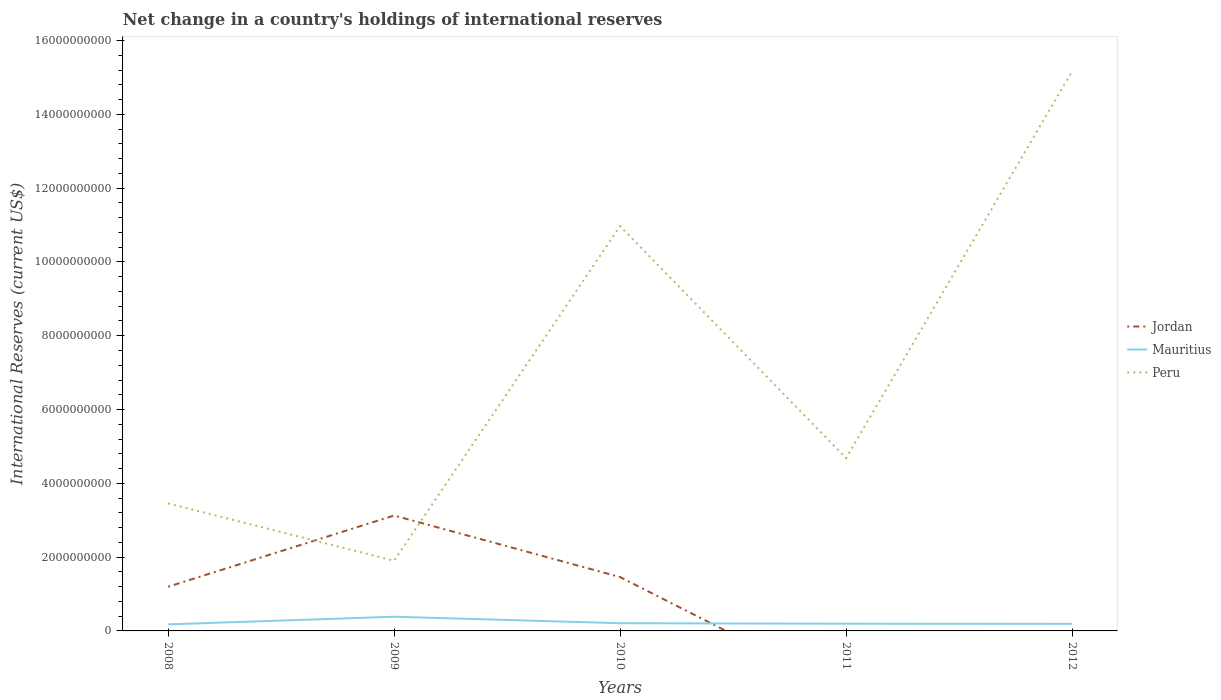Does the line corresponding to Jordan intersect with the line corresponding to Mauritius?
Your response must be concise. Yes. Is the number of lines equal to the number of legend labels?
Ensure brevity in your answer.  No. Across all years, what is the maximum international reserves in Mauritius?
Provide a short and direct response. 1.78e+08. What is the total international reserves in Mauritius in the graph?
Your answer should be very brief. -1.72e+07. What is the difference between the highest and the second highest international reserves in Peru?
Provide a succinct answer. 1.33e+1. How many lines are there?
Offer a terse response. 3. Does the graph contain any zero values?
Give a very brief answer. Yes. Where does the legend appear in the graph?
Make the answer very short. Center right. How many legend labels are there?
Your answer should be very brief. 3. What is the title of the graph?
Make the answer very short. Net change in a country's holdings of international reserves. Does "Heavily indebted poor countries" appear as one of the legend labels in the graph?
Offer a very short reply. No. What is the label or title of the X-axis?
Your answer should be very brief. Years. What is the label or title of the Y-axis?
Make the answer very short. International Reserves (current US$). What is the International Reserves (current US$) in Jordan in 2008?
Provide a succinct answer. 1.20e+09. What is the International Reserves (current US$) of Mauritius in 2008?
Provide a short and direct response. 1.78e+08. What is the International Reserves (current US$) of Peru in 2008?
Ensure brevity in your answer.  3.46e+09. What is the International Reserves (current US$) of Jordan in 2009?
Ensure brevity in your answer.  3.13e+09. What is the International Reserves (current US$) in Mauritius in 2009?
Your answer should be very brief. 3.85e+08. What is the International Reserves (current US$) in Peru in 2009?
Ensure brevity in your answer.  1.90e+09. What is the International Reserves (current US$) of Jordan in 2010?
Ensure brevity in your answer.  1.46e+09. What is the International Reserves (current US$) in Mauritius in 2010?
Provide a succinct answer. 2.09e+08. What is the International Reserves (current US$) of Peru in 2010?
Keep it short and to the point. 1.10e+1. What is the International Reserves (current US$) in Jordan in 2011?
Your answer should be very brief. 0. What is the International Reserves (current US$) in Mauritius in 2011?
Provide a succinct answer. 1.95e+08. What is the International Reserves (current US$) in Peru in 2011?
Provide a succinct answer. 4.68e+09. What is the International Reserves (current US$) of Jordan in 2012?
Your answer should be very brief. 0. What is the International Reserves (current US$) of Mauritius in 2012?
Your answer should be very brief. 1.92e+08. What is the International Reserves (current US$) in Peru in 2012?
Make the answer very short. 1.52e+1. Across all years, what is the maximum International Reserves (current US$) of Jordan?
Make the answer very short. 3.13e+09. Across all years, what is the maximum International Reserves (current US$) in Mauritius?
Make the answer very short. 3.85e+08. Across all years, what is the maximum International Reserves (current US$) in Peru?
Your answer should be compact. 1.52e+1. Across all years, what is the minimum International Reserves (current US$) in Mauritius?
Your answer should be very brief. 1.78e+08. Across all years, what is the minimum International Reserves (current US$) of Peru?
Offer a very short reply. 1.90e+09. What is the total International Reserves (current US$) in Jordan in the graph?
Give a very brief answer. 5.78e+09. What is the total International Reserves (current US$) in Mauritius in the graph?
Your response must be concise. 1.16e+09. What is the total International Reserves (current US$) of Peru in the graph?
Offer a terse response. 3.62e+1. What is the difference between the International Reserves (current US$) of Jordan in 2008 and that in 2009?
Your answer should be compact. -1.93e+09. What is the difference between the International Reserves (current US$) in Mauritius in 2008 and that in 2009?
Your answer should be compact. -2.07e+08. What is the difference between the International Reserves (current US$) in Peru in 2008 and that in 2009?
Offer a very short reply. 1.55e+09. What is the difference between the International Reserves (current US$) in Jordan in 2008 and that in 2010?
Your answer should be compact. -2.63e+08. What is the difference between the International Reserves (current US$) of Mauritius in 2008 and that in 2010?
Give a very brief answer. -3.12e+07. What is the difference between the International Reserves (current US$) in Peru in 2008 and that in 2010?
Give a very brief answer. -7.51e+09. What is the difference between the International Reserves (current US$) of Mauritius in 2008 and that in 2011?
Keep it short and to the point. -1.72e+07. What is the difference between the International Reserves (current US$) in Peru in 2008 and that in 2011?
Your answer should be compact. -1.23e+09. What is the difference between the International Reserves (current US$) in Mauritius in 2008 and that in 2012?
Provide a succinct answer. -1.37e+07. What is the difference between the International Reserves (current US$) of Peru in 2008 and that in 2012?
Your answer should be compact. -1.17e+1. What is the difference between the International Reserves (current US$) in Jordan in 2009 and that in 2010?
Provide a succinct answer. 1.67e+09. What is the difference between the International Reserves (current US$) in Mauritius in 2009 and that in 2010?
Provide a succinct answer. 1.76e+08. What is the difference between the International Reserves (current US$) in Peru in 2009 and that in 2010?
Your answer should be compact. -9.07e+09. What is the difference between the International Reserves (current US$) in Mauritius in 2009 and that in 2011?
Ensure brevity in your answer.  1.90e+08. What is the difference between the International Reserves (current US$) in Peru in 2009 and that in 2011?
Offer a terse response. -2.78e+09. What is the difference between the International Reserves (current US$) in Mauritius in 2009 and that in 2012?
Offer a very short reply. 1.93e+08. What is the difference between the International Reserves (current US$) in Peru in 2009 and that in 2012?
Offer a terse response. -1.33e+1. What is the difference between the International Reserves (current US$) of Mauritius in 2010 and that in 2011?
Offer a terse response. 1.39e+07. What is the difference between the International Reserves (current US$) in Peru in 2010 and that in 2011?
Offer a very short reply. 6.29e+09. What is the difference between the International Reserves (current US$) of Mauritius in 2010 and that in 2012?
Provide a succinct answer. 1.75e+07. What is the difference between the International Reserves (current US$) in Peru in 2010 and that in 2012?
Provide a succinct answer. -4.20e+09. What is the difference between the International Reserves (current US$) in Mauritius in 2011 and that in 2012?
Give a very brief answer. 3.58e+06. What is the difference between the International Reserves (current US$) in Peru in 2011 and that in 2012?
Ensure brevity in your answer.  -1.05e+1. What is the difference between the International Reserves (current US$) of Jordan in 2008 and the International Reserves (current US$) of Mauritius in 2009?
Ensure brevity in your answer.  8.12e+08. What is the difference between the International Reserves (current US$) of Jordan in 2008 and the International Reserves (current US$) of Peru in 2009?
Ensure brevity in your answer.  -7.05e+08. What is the difference between the International Reserves (current US$) of Mauritius in 2008 and the International Reserves (current US$) of Peru in 2009?
Provide a short and direct response. -1.72e+09. What is the difference between the International Reserves (current US$) in Jordan in 2008 and the International Reserves (current US$) in Mauritius in 2010?
Provide a succinct answer. 9.88e+08. What is the difference between the International Reserves (current US$) of Jordan in 2008 and the International Reserves (current US$) of Peru in 2010?
Your answer should be compact. -9.77e+09. What is the difference between the International Reserves (current US$) of Mauritius in 2008 and the International Reserves (current US$) of Peru in 2010?
Offer a terse response. -1.08e+1. What is the difference between the International Reserves (current US$) of Jordan in 2008 and the International Reserves (current US$) of Mauritius in 2011?
Provide a succinct answer. 1.00e+09. What is the difference between the International Reserves (current US$) in Jordan in 2008 and the International Reserves (current US$) in Peru in 2011?
Offer a very short reply. -3.49e+09. What is the difference between the International Reserves (current US$) in Mauritius in 2008 and the International Reserves (current US$) in Peru in 2011?
Keep it short and to the point. -4.51e+09. What is the difference between the International Reserves (current US$) of Jordan in 2008 and the International Reserves (current US$) of Mauritius in 2012?
Give a very brief answer. 1.01e+09. What is the difference between the International Reserves (current US$) of Jordan in 2008 and the International Reserves (current US$) of Peru in 2012?
Provide a short and direct response. -1.40e+1. What is the difference between the International Reserves (current US$) of Mauritius in 2008 and the International Reserves (current US$) of Peru in 2012?
Offer a very short reply. -1.50e+1. What is the difference between the International Reserves (current US$) of Jordan in 2009 and the International Reserves (current US$) of Mauritius in 2010?
Provide a short and direct response. 2.92e+09. What is the difference between the International Reserves (current US$) in Jordan in 2009 and the International Reserves (current US$) in Peru in 2010?
Give a very brief answer. -7.84e+09. What is the difference between the International Reserves (current US$) in Mauritius in 2009 and the International Reserves (current US$) in Peru in 2010?
Your response must be concise. -1.06e+1. What is the difference between the International Reserves (current US$) of Jordan in 2009 and the International Reserves (current US$) of Mauritius in 2011?
Offer a terse response. 2.93e+09. What is the difference between the International Reserves (current US$) of Jordan in 2009 and the International Reserves (current US$) of Peru in 2011?
Offer a very short reply. -1.56e+09. What is the difference between the International Reserves (current US$) in Mauritius in 2009 and the International Reserves (current US$) in Peru in 2011?
Offer a terse response. -4.30e+09. What is the difference between the International Reserves (current US$) in Jordan in 2009 and the International Reserves (current US$) in Mauritius in 2012?
Your answer should be very brief. 2.94e+09. What is the difference between the International Reserves (current US$) in Jordan in 2009 and the International Reserves (current US$) in Peru in 2012?
Offer a very short reply. -1.20e+1. What is the difference between the International Reserves (current US$) in Mauritius in 2009 and the International Reserves (current US$) in Peru in 2012?
Your answer should be compact. -1.48e+1. What is the difference between the International Reserves (current US$) in Jordan in 2010 and the International Reserves (current US$) in Mauritius in 2011?
Keep it short and to the point. 1.26e+09. What is the difference between the International Reserves (current US$) of Jordan in 2010 and the International Reserves (current US$) of Peru in 2011?
Your response must be concise. -3.22e+09. What is the difference between the International Reserves (current US$) of Mauritius in 2010 and the International Reserves (current US$) of Peru in 2011?
Offer a very short reply. -4.47e+09. What is the difference between the International Reserves (current US$) of Jordan in 2010 and the International Reserves (current US$) of Mauritius in 2012?
Ensure brevity in your answer.  1.27e+09. What is the difference between the International Reserves (current US$) in Jordan in 2010 and the International Reserves (current US$) in Peru in 2012?
Make the answer very short. -1.37e+1. What is the difference between the International Reserves (current US$) of Mauritius in 2010 and the International Reserves (current US$) of Peru in 2012?
Your response must be concise. -1.50e+1. What is the difference between the International Reserves (current US$) of Mauritius in 2011 and the International Reserves (current US$) of Peru in 2012?
Your response must be concise. -1.50e+1. What is the average International Reserves (current US$) in Jordan per year?
Keep it short and to the point. 1.16e+09. What is the average International Reserves (current US$) in Mauritius per year?
Offer a very short reply. 2.32e+08. What is the average International Reserves (current US$) in Peru per year?
Offer a terse response. 7.24e+09. In the year 2008, what is the difference between the International Reserves (current US$) in Jordan and International Reserves (current US$) in Mauritius?
Offer a terse response. 1.02e+09. In the year 2008, what is the difference between the International Reserves (current US$) in Jordan and International Reserves (current US$) in Peru?
Offer a terse response. -2.26e+09. In the year 2008, what is the difference between the International Reserves (current US$) in Mauritius and International Reserves (current US$) in Peru?
Your answer should be compact. -3.28e+09. In the year 2009, what is the difference between the International Reserves (current US$) in Jordan and International Reserves (current US$) in Mauritius?
Your response must be concise. 2.74e+09. In the year 2009, what is the difference between the International Reserves (current US$) in Jordan and International Reserves (current US$) in Peru?
Your response must be concise. 1.23e+09. In the year 2009, what is the difference between the International Reserves (current US$) in Mauritius and International Reserves (current US$) in Peru?
Provide a short and direct response. -1.52e+09. In the year 2010, what is the difference between the International Reserves (current US$) of Jordan and International Reserves (current US$) of Mauritius?
Provide a short and direct response. 1.25e+09. In the year 2010, what is the difference between the International Reserves (current US$) in Jordan and International Reserves (current US$) in Peru?
Keep it short and to the point. -9.51e+09. In the year 2010, what is the difference between the International Reserves (current US$) in Mauritius and International Reserves (current US$) in Peru?
Give a very brief answer. -1.08e+1. In the year 2011, what is the difference between the International Reserves (current US$) in Mauritius and International Reserves (current US$) in Peru?
Your response must be concise. -4.49e+09. In the year 2012, what is the difference between the International Reserves (current US$) of Mauritius and International Reserves (current US$) of Peru?
Offer a terse response. -1.50e+1. What is the ratio of the International Reserves (current US$) of Jordan in 2008 to that in 2009?
Ensure brevity in your answer.  0.38. What is the ratio of the International Reserves (current US$) in Mauritius in 2008 to that in 2009?
Your response must be concise. 0.46. What is the ratio of the International Reserves (current US$) in Peru in 2008 to that in 2009?
Make the answer very short. 1.82. What is the ratio of the International Reserves (current US$) in Jordan in 2008 to that in 2010?
Provide a succinct answer. 0.82. What is the ratio of the International Reserves (current US$) in Mauritius in 2008 to that in 2010?
Offer a terse response. 0.85. What is the ratio of the International Reserves (current US$) of Peru in 2008 to that in 2010?
Give a very brief answer. 0.32. What is the ratio of the International Reserves (current US$) in Mauritius in 2008 to that in 2011?
Provide a succinct answer. 0.91. What is the ratio of the International Reserves (current US$) of Peru in 2008 to that in 2011?
Ensure brevity in your answer.  0.74. What is the ratio of the International Reserves (current US$) of Mauritius in 2008 to that in 2012?
Your response must be concise. 0.93. What is the ratio of the International Reserves (current US$) of Peru in 2008 to that in 2012?
Offer a terse response. 0.23. What is the ratio of the International Reserves (current US$) in Jordan in 2009 to that in 2010?
Offer a very short reply. 2.14. What is the ratio of the International Reserves (current US$) of Mauritius in 2009 to that in 2010?
Your answer should be compact. 1.84. What is the ratio of the International Reserves (current US$) in Peru in 2009 to that in 2010?
Your response must be concise. 0.17. What is the ratio of the International Reserves (current US$) in Mauritius in 2009 to that in 2011?
Your answer should be compact. 1.97. What is the ratio of the International Reserves (current US$) of Peru in 2009 to that in 2011?
Offer a terse response. 0.41. What is the ratio of the International Reserves (current US$) of Mauritius in 2009 to that in 2012?
Ensure brevity in your answer.  2.01. What is the ratio of the International Reserves (current US$) in Peru in 2009 to that in 2012?
Ensure brevity in your answer.  0.13. What is the ratio of the International Reserves (current US$) of Mauritius in 2010 to that in 2011?
Provide a succinct answer. 1.07. What is the ratio of the International Reserves (current US$) of Peru in 2010 to that in 2011?
Your answer should be compact. 2.34. What is the ratio of the International Reserves (current US$) of Mauritius in 2010 to that in 2012?
Give a very brief answer. 1.09. What is the ratio of the International Reserves (current US$) of Peru in 2010 to that in 2012?
Your response must be concise. 0.72. What is the ratio of the International Reserves (current US$) in Mauritius in 2011 to that in 2012?
Keep it short and to the point. 1.02. What is the ratio of the International Reserves (current US$) of Peru in 2011 to that in 2012?
Offer a terse response. 0.31. What is the difference between the highest and the second highest International Reserves (current US$) of Jordan?
Your answer should be compact. 1.67e+09. What is the difference between the highest and the second highest International Reserves (current US$) in Mauritius?
Offer a very short reply. 1.76e+08. What is the difference between the highest and the second highest International Reserves (current US$) in Peru?
Provide a succinct answer. 4.20e+09. What is the difference between the highest and the lowest International Reserves (current US$) of Jordan?
Your response must be concise. 3.13e+09. What is the difference between the highest and the lowest International Reserves (current US$) in Mauritius?
Keep it short and to the point. 2.07e+08. What is the difference between the highest and the lowest International Reserves (current US$) of Peru?
Offer a terse response. 1.33e+1. 